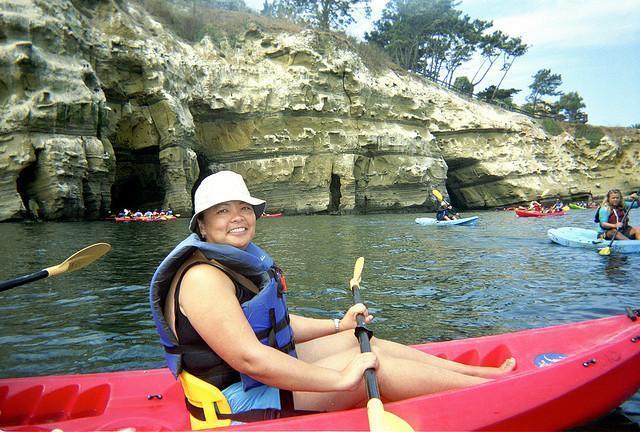How many boats are there?
Give a very brief answer. 6. 